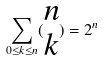<formula> <loc_0><loc_0><loc_500><loc_500>\sum _ { 0 \leq k \leq n } ( \begin{matrix} n \\ k \end{matrix} ) = 2 ^ { n }</formula> 